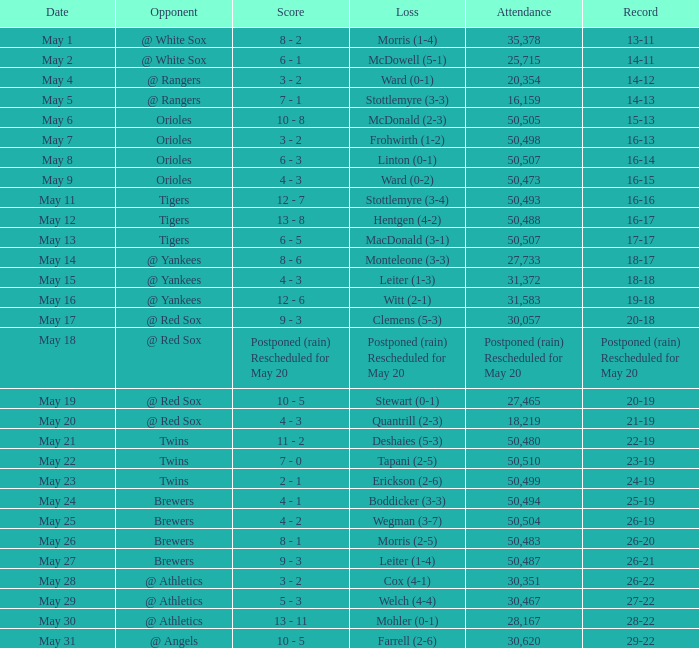Can you tell me the score of the may 9th game? 4 - 3. 